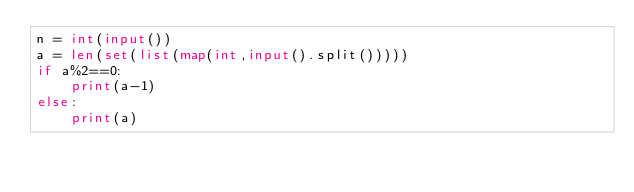<code> <loc_0><loc_0><loc_500><loc_500><_Python_>n = int(input())
a = len(set(list(map(int,input().split()))))
if a%2==0:
    print(a-1)
else:
    print(a)
</code> 